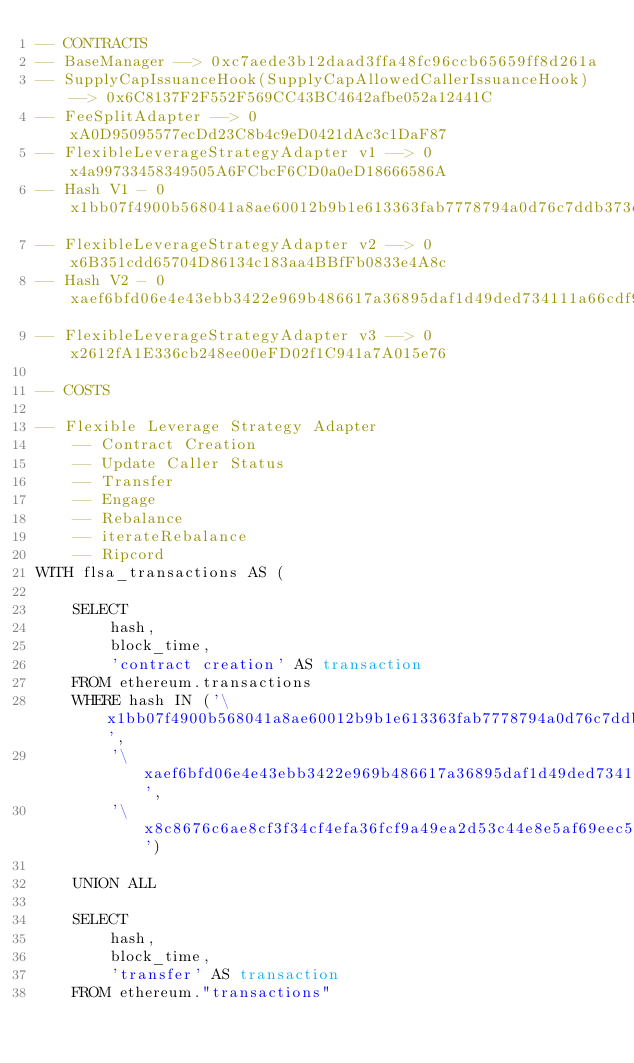Convert code to text. <code><loc_0><loc_0><loc_500><loc_500><_SQL_>-- CONTRACTS
-- BaseManager --> 0xc7aede3b12daad3ffa48fc96ccb65659ff8d261a
-- SupplyCapIssuanceHook(SupplyCapAllowedCallerIssuanceHook) --> 0x6C8137F2F552F569CC43BC4642afbe052a12441C
-- FeeSplitAdapter --> 0xA0D95095577ecDd23C8b4c9eD0421dAc3c1DaF87
-- FlexibleLeverageStrategyAdapter v1 --> 0x4a99733458349505A6FCbcF6CD0a0eD18666586A
-- Hash V1 - 0x1bb07f4900b568041a8ae60012b9b1e613363fab7778794a0d76c7ddb373ebe1
-- FlexibleLeverageStrategyAdapter v2 --> 0x6B351cdd65704D86134c183aa4BBfFb0833e4A8c
-- Hash V2 - 0xaef6bfd06e4e43ebb3422e969b486617a36895daf1d49ded734111a66cdf9ea2
-- FlexibleLeverageStrategyAdapter v3 --> 0x2612fA1E336cb248ee00eFD02f1C941a7A015e76

-- COSTS

-- Flexible Leverage Strategy Adapter
    -- Contract Creation
    -- Update Caller Status
    -- Transfer
    -- Engage
    -- Rebalance
    -- iterateRebalance
    -- Ripcord
WITH flsa_transactions AS (

    SELECT
        hash,
        block_time,
        'contract creation' AS transaction
    FROM ethereum.transactions
    WHERE hash IN ('\x1bb07f4900b568041a8ae60012b9b1e613363fab7778794a0d76c7ddb373ebe1',
        '\xaef6bfd06e4e43ebb3422e969b486617a36895daf1d49ded734111a66cdf9ea2', 
        '\x8c8676c6ae8cf3f34cf4efa36fcf9a49ea2d53c44e8e5af69eec52d3b8694812')
    
    UNION ALL
    
    SELECT
        hash,
        block_time,
        'transfer' AS transaction
    FROM ethereum."transactions"</code> 